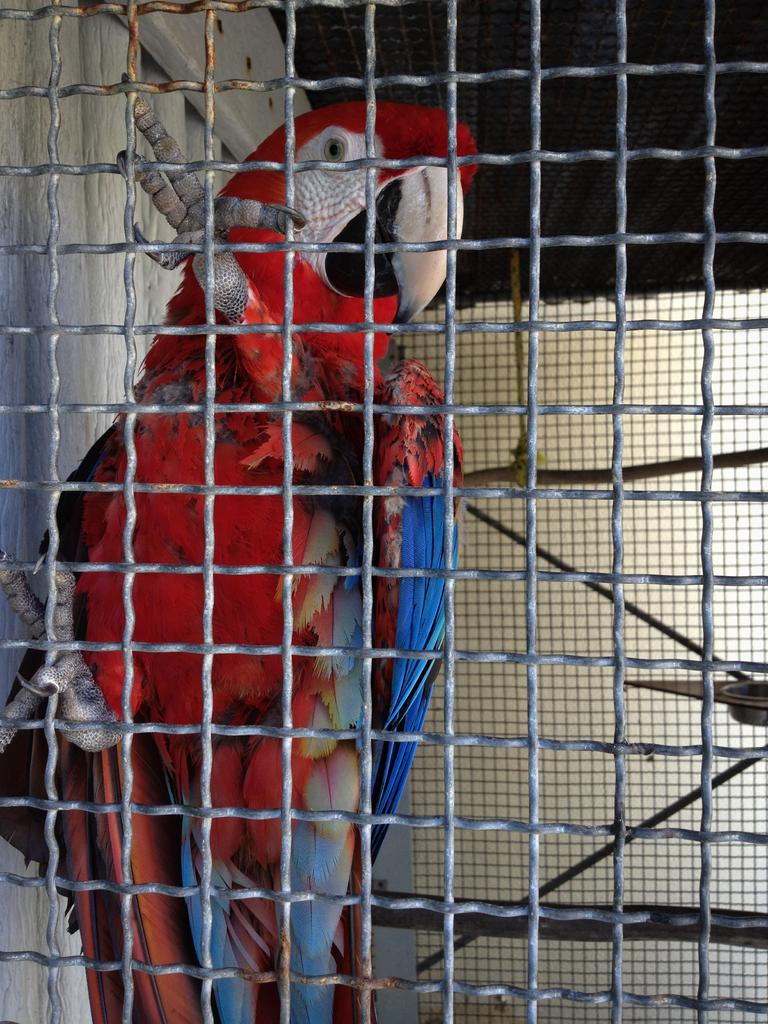What type of animal is in the picture? There is a parrot in the picture. What colors can be seen on the parrot? The parrot is red and blue in color. Where is the parrot located in the picture? The parrot is inside a cage. What type of curtain can be seen hanging from the parrot's beak in the image? There is no curtain present in the image, and the parrot's beak is not holding any object. 